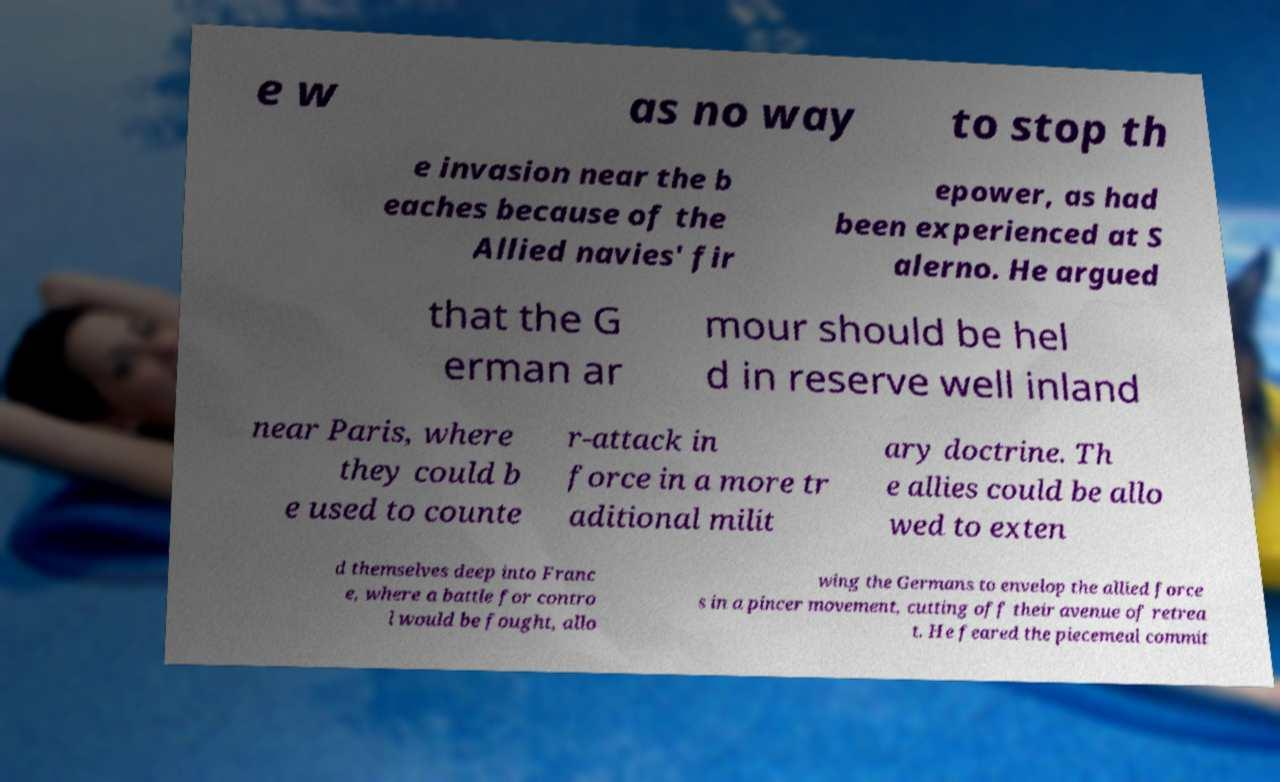Could you extract and type out the text from this image? e w as no way to stop th e invasion near the b eaches because of the Allied navies' fir epower, as had been experienced at S alerno. He argued that the G erman ar mour should be hel d in reserve well inland near Paris, where they could b e used to counte r-attack in force in a more tr aditional milit ary doctrine. Th e allies could be allo wed to exten d themselves deep into Franc e, where a battle for contro l would be fought, allo wing the Germans to envelop the allied force s in a pincer movement, cutting off their avenue of retrea t. He feared the piecemeal commit 